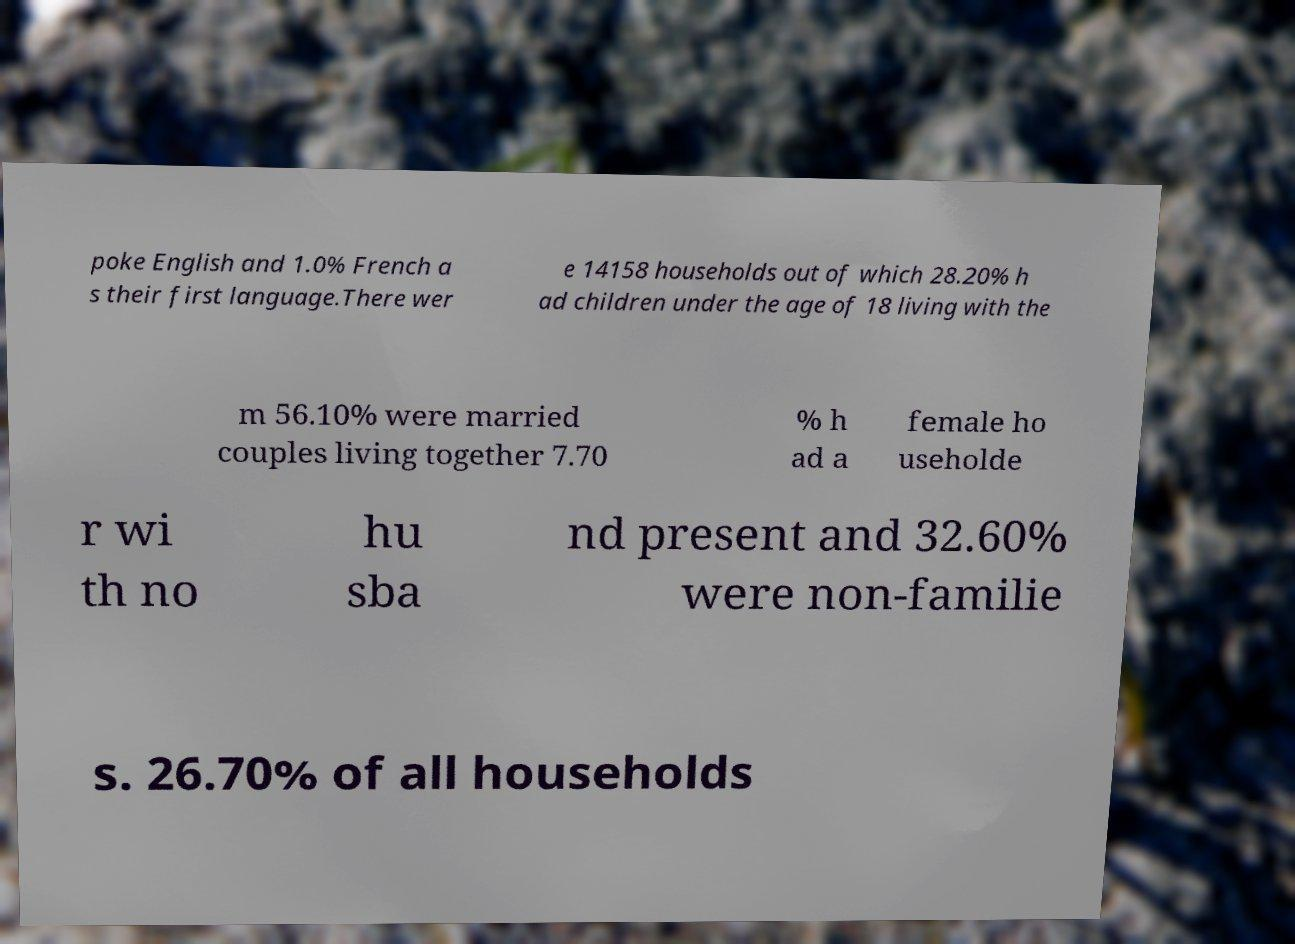There's text embedded in this image that I need extracted. Can you transcribe it verbatim? poke English and 1.0% French a s their first language.There wer e 14158 households out of which 28.20% h ad children under the age of 18 living with the m 56.10% were married couples living together 7.70 % h ad a female ho useholde r wi th no hu sba nd present and 32.60% were non-familie s. 26.70% of all households 